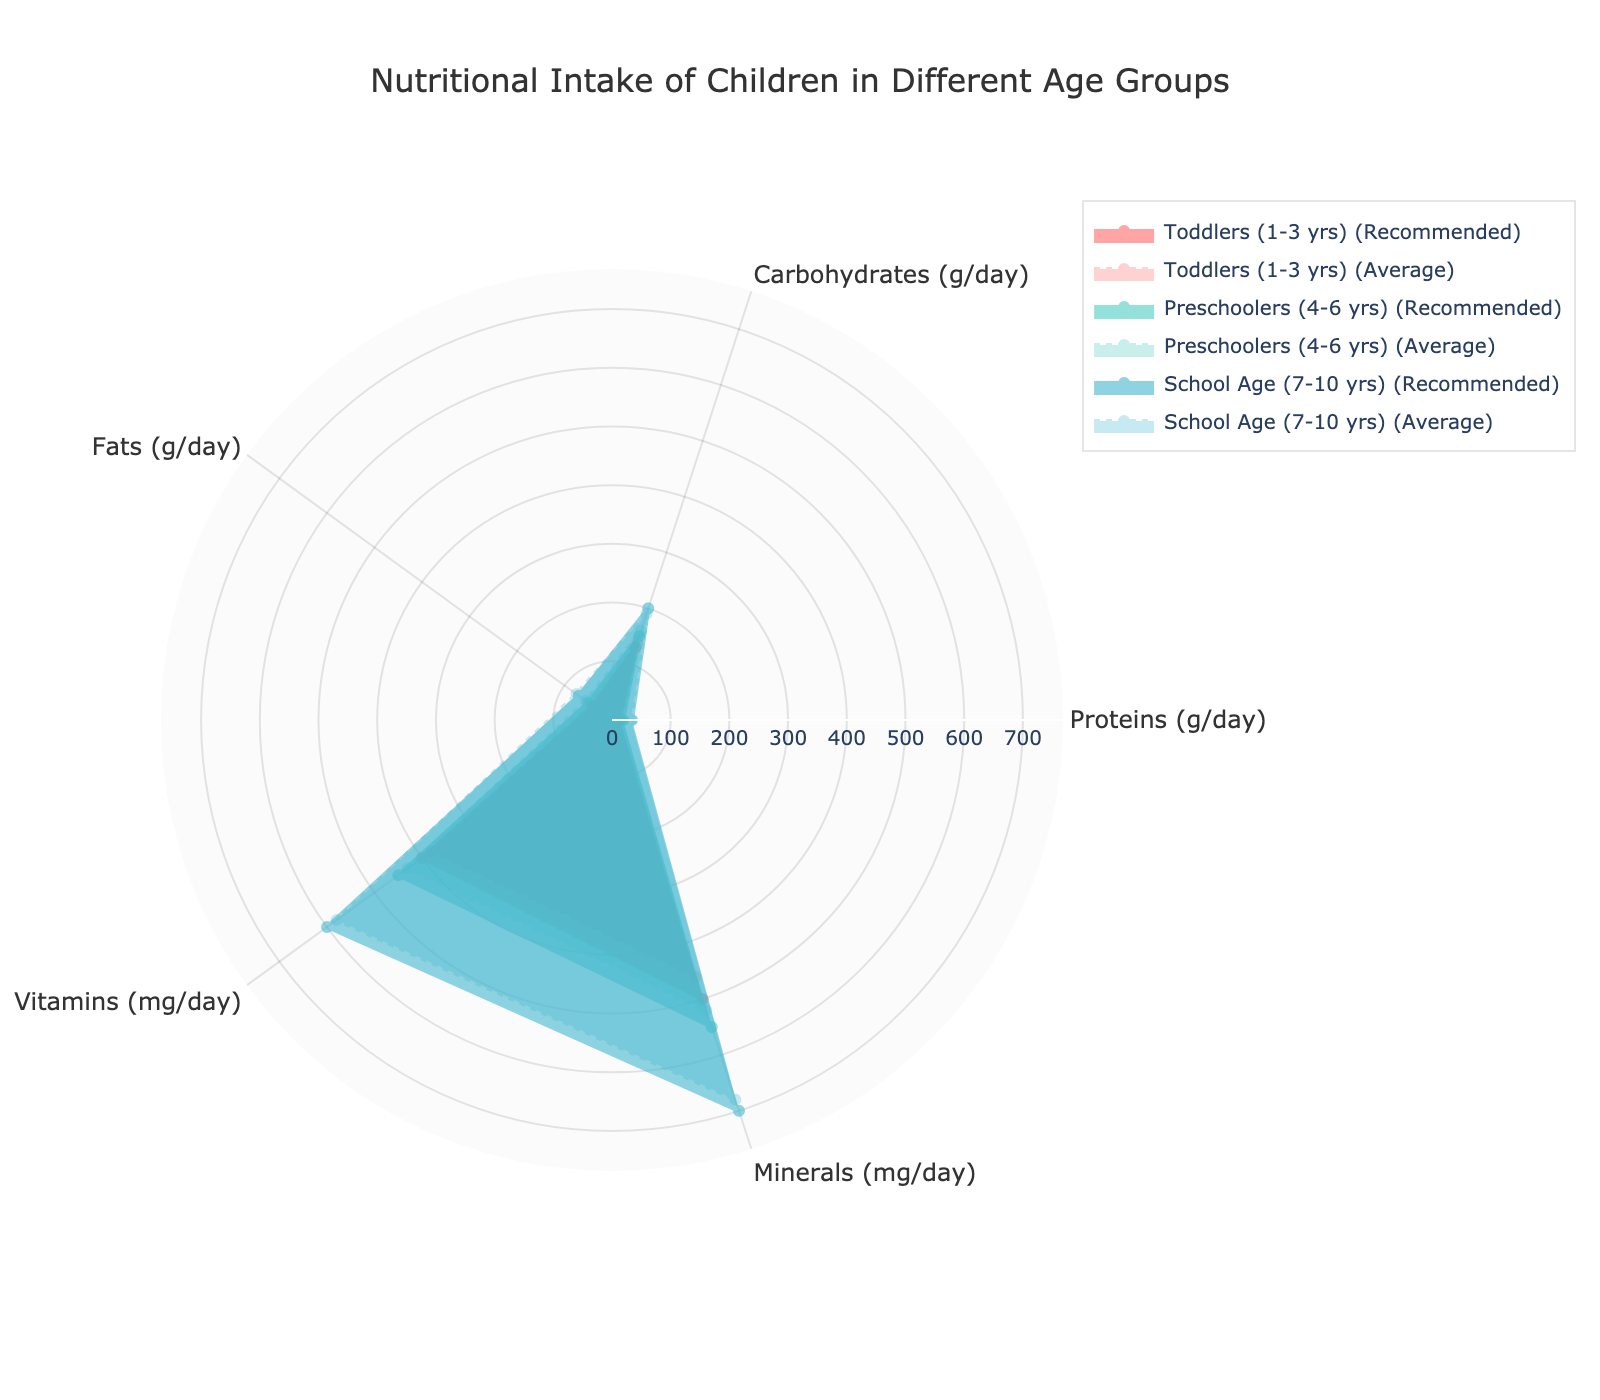what is the title of the chart? The title can be found at the top of the radar chart. It serves to describe what the chart represents. The title in this chart indicates the focus of the radar chart on nutritional intake of children across different age groups.
Answer: Nutritional Intake of Children in Different Age Groups How does the average intake of proteins for toddlers compare to the recommended intake? To answer this, look at the area representing "Toddlers (1-3 yrs)" on the radar chart. Compare the protein value for the "Average Intake" (dashed line) to the "Recommended Intake" (solid line).
Answer: Average intake of protein for toddlers is higher than the recommended intake Which age group has the highest recommended intake of vitamins? Look at the values in the radar chart under the "Vitamins" axis. Identify the group that extends furthest outwards on this axis under the "Recommended Intake".
Answer: School Age (7-10 yrs) What is the difference between the average and recommended intake of fats for preschoolers? Look at the "Fats (g/day)" axis for the "Preschoolers (4-6 yrs)" group on the radar chart. Find the difference between the "Average Intake" value (dotted line) and the "Recommended Intake" value (solid line).
Answer: 5 g/day Compare the mineral intake of toddlers and school-age children based on the average values. Look at the "Minerals (mg/day)" axis for both "Toddlers (1-3 yrs)" and "School Age (7-10 yrs)" on the radar chart. Compare the average intake (dotted lines) of each group.
Answer: School-age children have a higher average intake than toddlers Which nutrient shows the smallest discrepancy between recommended and average intake for school-age children? Focus on the "School Age (7-10 yrs)" group and visually assess the gap between the solid and dotted lines for each nutrient. The nutrient with the smallest gap is the one with the smallest discrepancy.
Answer: Carbohydrates For which age group is the carbohydrate intake above the recommended level in the average case? Look at the "Carbohydrates (g/day)" axis for each age group and compare the "Average Intake" to the "Recommended Intake".
Answer: Preschoolers (4-6 yrs) How does the average intake of minerals change from toddlers to preschoolers? Examine the "Minerals (mg/day)" axis on the radar chart for both "Toddlers (1-3 yrs)" and "Preschoolers (4-6 yrs)" groups. Compare the average intake values.
Answer: Increases by 60 mg/day 